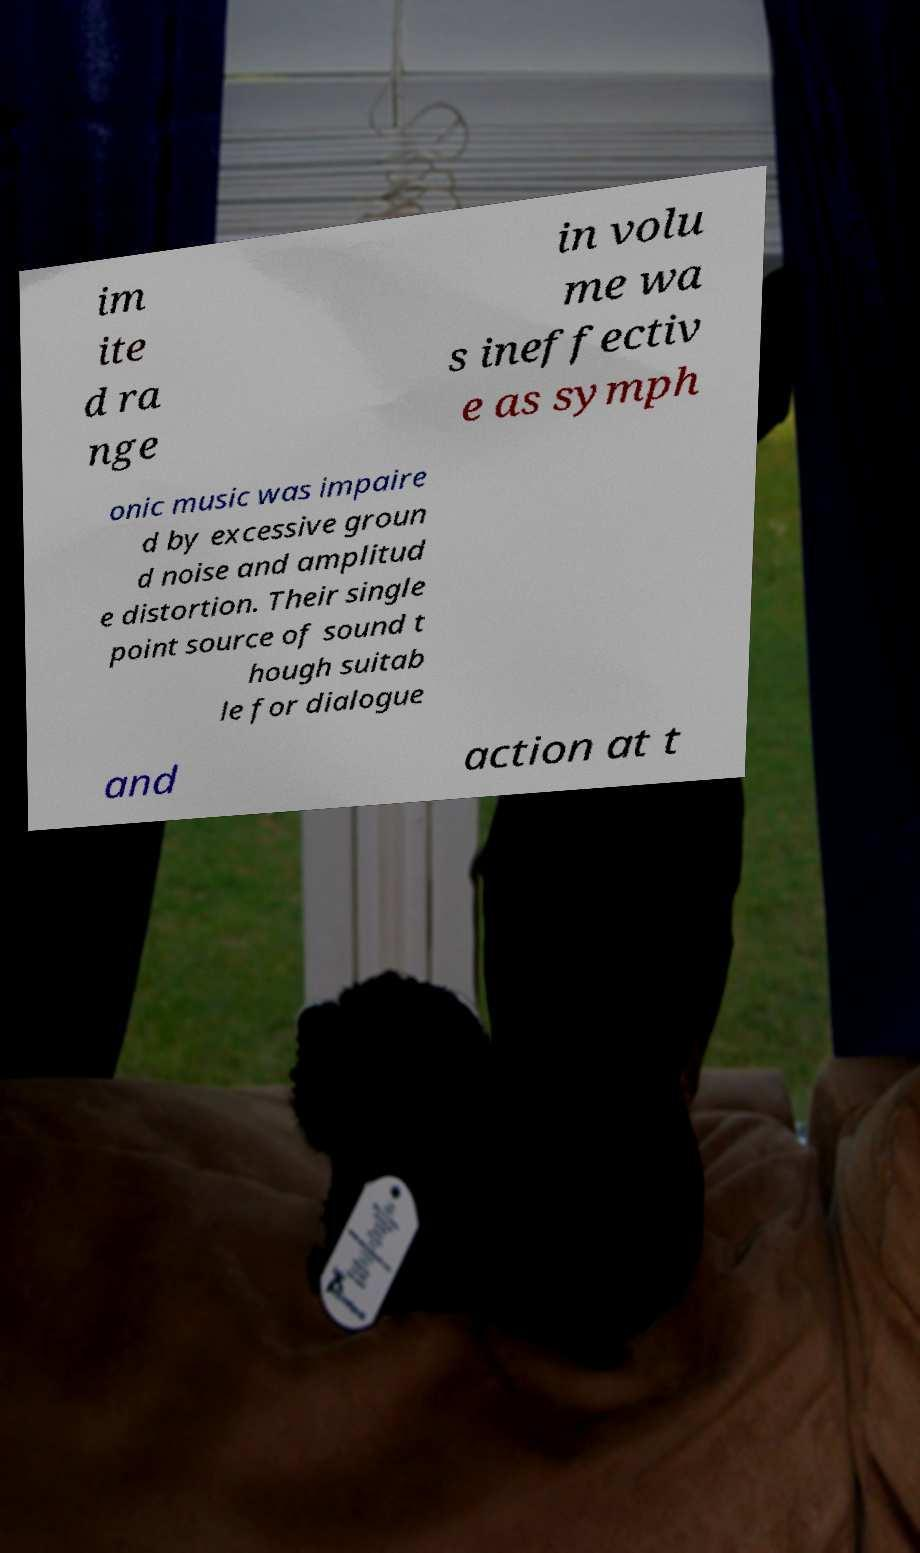Please read and relay the text visible in this image. What does it say? im ite d ra nge in volu me wa s ineffectiv e as symph onic music was impaire d by excessive groun d noise and amplitud e distortion. Their single point source of sound t hough suitab le for dialogue and action at t 